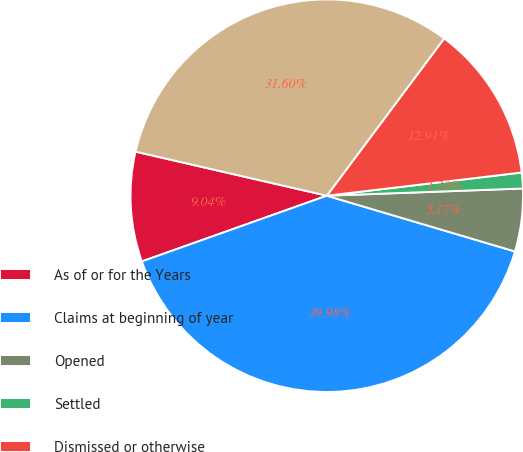Convert chart to OTSL. <chart><loc_0><loc_0><loc_500><loc_500><pie_chart><fcel>As of or for the Years<fcel>Claims at beginning of year<fcel>Opened<fcel>Settled<fcel>Dismissed or otherwise<fcel>Claims at end of year<nl><fcel>9.04%<fcel>39.98%<fcel>5.17%<fcel>1.3%<fcel>12.91%<fcel>31.6%<nl></chart> 